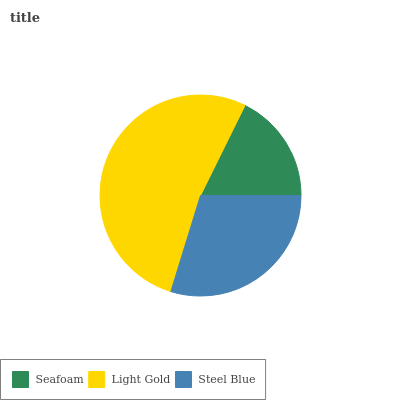Is Seafoam the minimum?
Answer yes or no. Yes. Is Light Gold the maximum?
Answer yes or no. Yes. Is Steel Blue the minimum?
Answer yes or no. No. Is Steel Blue the maximum?
Answer yes or no. No. Is Light Gold greater than Steel Blue?
Answer yes or no. Yes. Is Steel Blue less than Light Gold?
Answer yes or no. Yes. Is Steel Blue greater than Light Gold?
Answer yes or no. No. Is Light Gold less than Steel Blue?
Answer yes or no. No. Is Steel Blue the high median?
Answer yes or no. Yes. Is Steel Blue the low median?
Answer yes or no. Yes. Is Seafoam the high median?
Answer yes or no. No. Is Light Gold the low median?
Answer yes or no. No. 